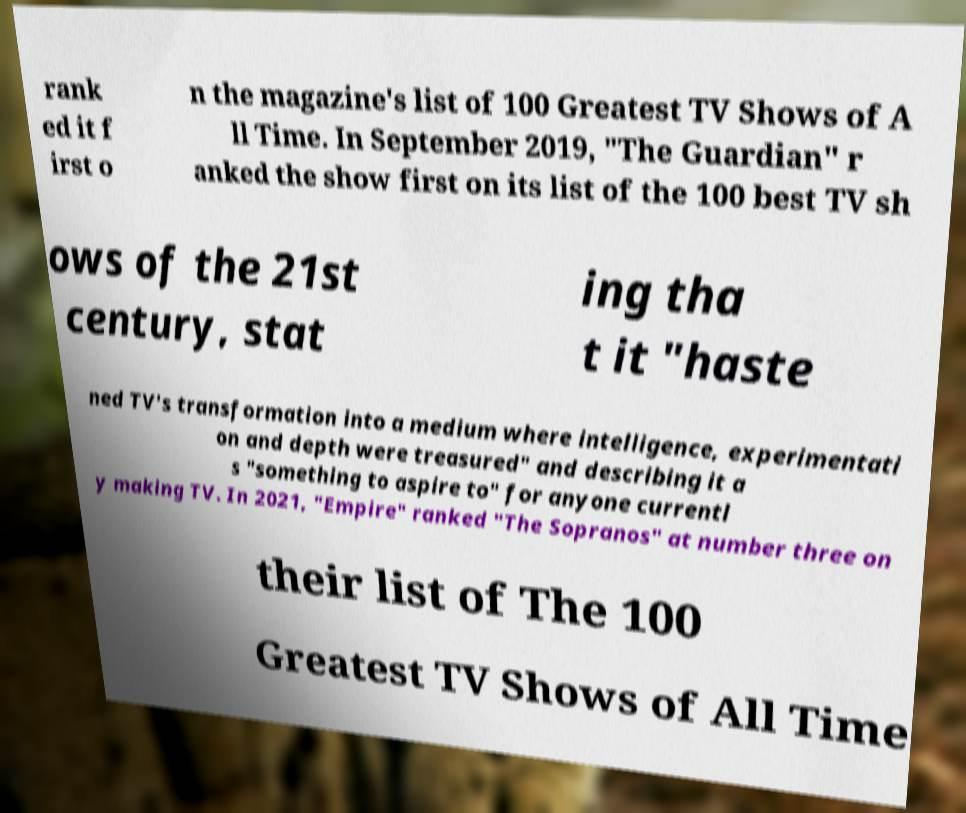Can you accurately transcribe the text from the provided image for me? rank ed it f irst o n the magazine's list of 100 Greatest TV Shows of A ll Time. In September 2019, "The Guardian" r anked the show first on its list of the 100 best TV sh ows of the 21st century, stat ing tha t it "haste ned TV's transformation into a medium where intelligence, experimentati on and depth were treasured" and describing it a s "something to aspire to" for anyone currentl y making TV. In 2021, "Empire" ranked "The Sopranos" at number three on their list of The 100 Greatest TV Shows of All Time 